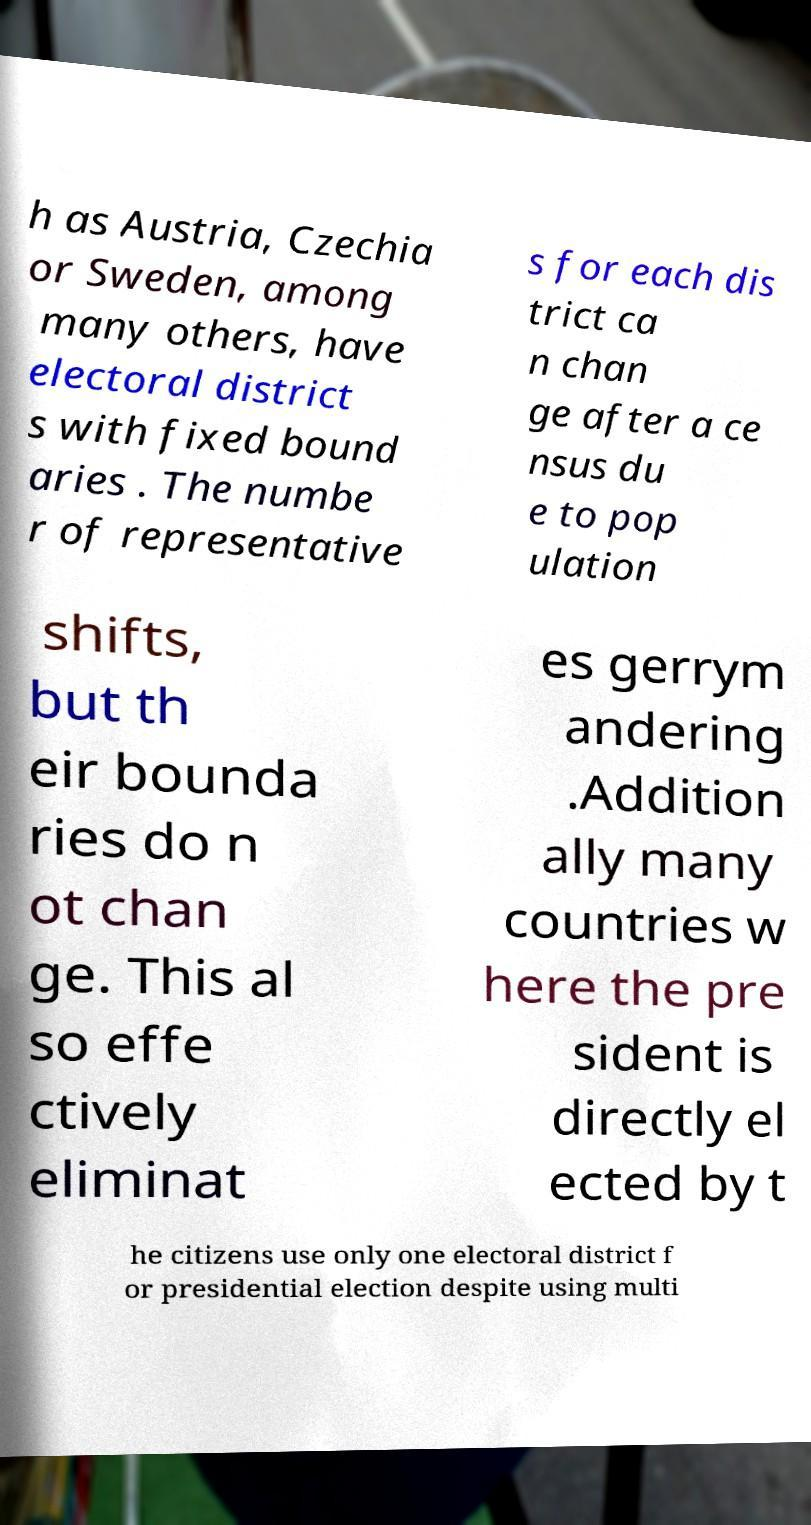There's text embedded in this image that I need extracted. Can you transcribe it verbatim? h as Austria, Czechia or Sweden, among many others, have electoral district s with fixed bound aries . The numbe r of representative s for each dis trict ca n chan ge after a ce nsus du e to pop ulation shifts, but th eir bounda ries do n ot chan ge. This al so effe ctively eliminat es gerrym andering .Addition ally many countries w here the pre sident is directly el ected by t he citizens use only one electoral district f or presidential election despite using multi 